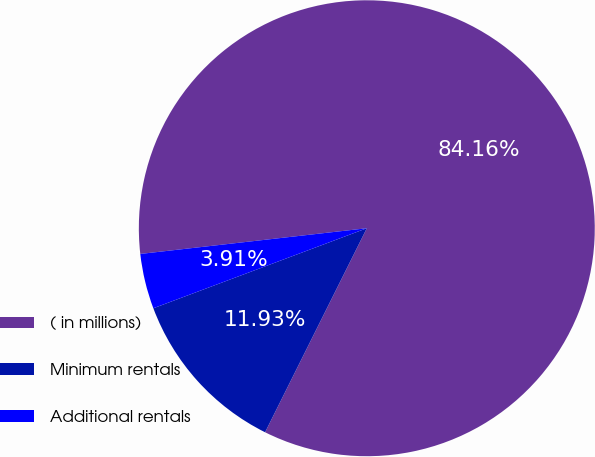Convert chart to OTSL. <chart><loc_0><loc_0><loc_500><loc_500><pie_chart><fcel>( in millions)<fcel>Minimum rentals<fcel>Additional rentals<nl><fcel>84.16%<fcel>11.93%<fcel>3.91%<nl></chart> 